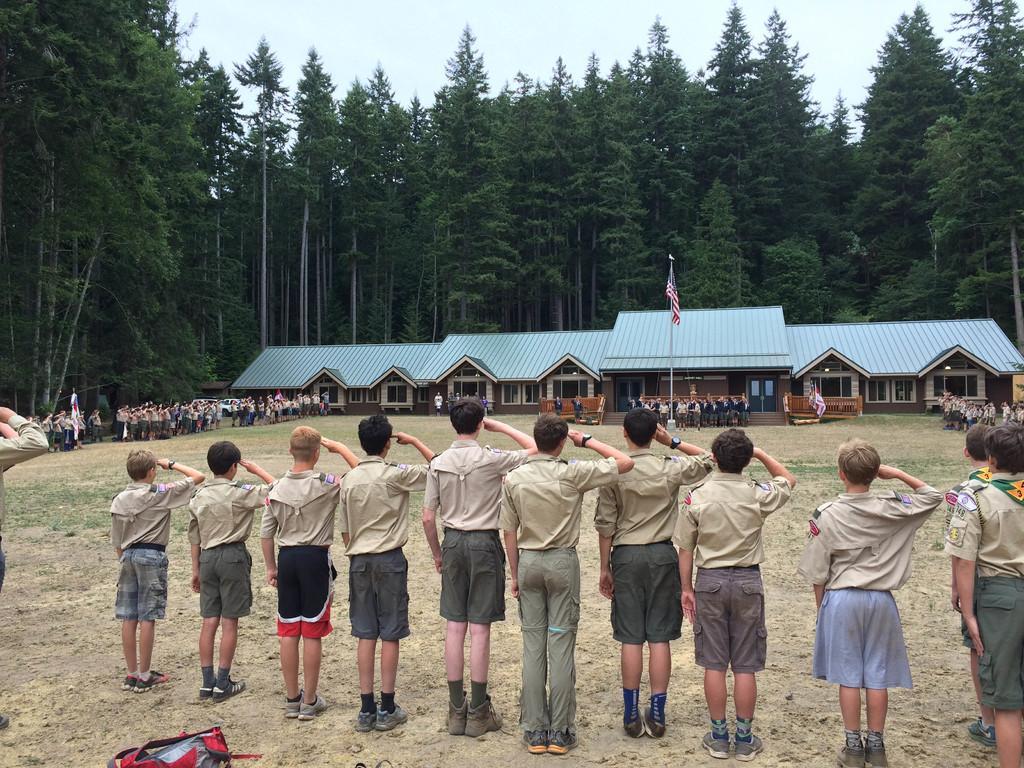How would you summarize this image in a sentence or two? In this picture we can see the group of persons who are wearing the same dress and they are saluting to the flag. In the background we can see the building and many trees. At the top we can see the sky and clouds. At the bottom we can see the bag near to the person. In front of the building we can see the group of persons standing near to the benches. On the left we can see another group of persons. 